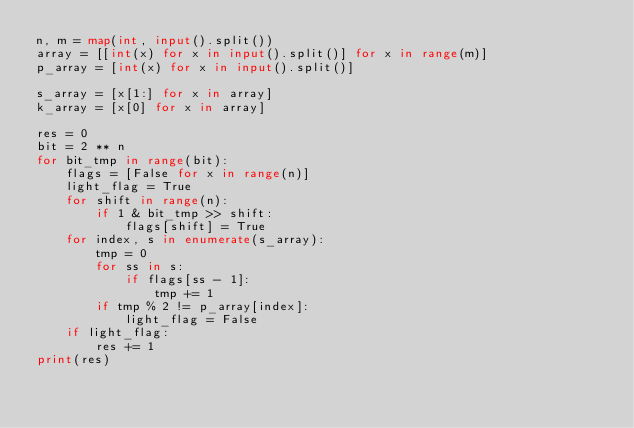<code> <loc_0><loc_0><loc_500><loc_500><_Python_>n, m = map(int, input().split())
array = [[int(x) for x in input().split()] for x in range(m)]
p_array = [int(x) for x in input().split()]

s_array = [x[1:] for x in array]
k_array = [x[0] for x in array]

res = 0
bit = 2 ** n
for bit_tmp in range(bit):
    flags = [False for x in range(n)]
    light_flag = True
    for shift in range(n):
        if 1 & bit_tmp >> shift:
            flags[shift] = True
    for index, s in enumerate(s_array):
        tmp = 0
        for ss in s:
            if flags[ss - 1]:
                tmp += 1
        if tmp % 2 != p_array[index]:
            light_flag = False
    if light_flag:
        res += 1
print(res)
</code> 